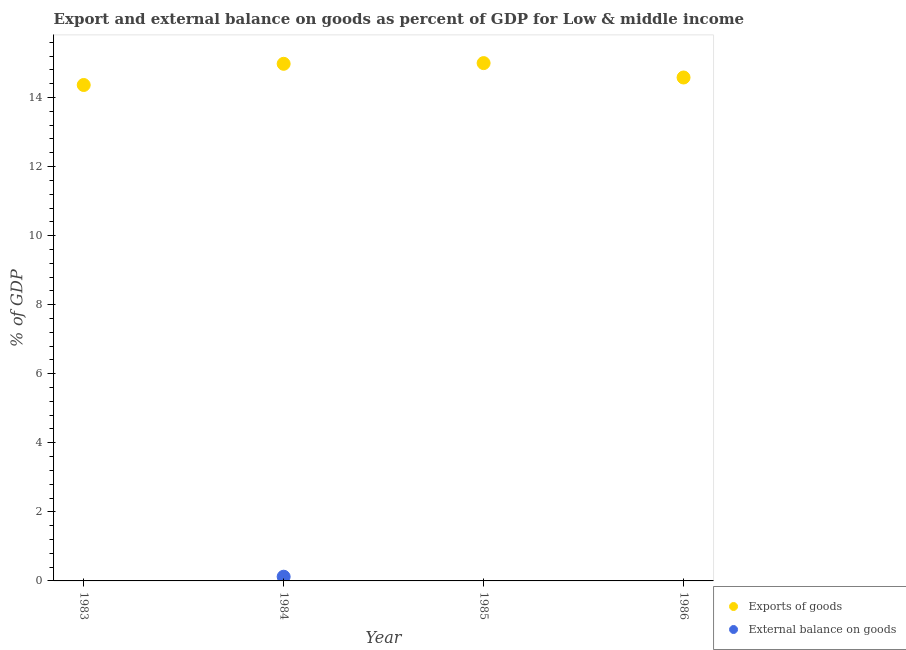Across all years, what is the maximum external balance on goods as percentage of gdp?
Your response must be concise. 0.12. Across all years, what is the minimum export of goods as percentage of gdp?
Offer a terse response. 14.36. What is the total export of goods as percentage of gdp in the graph?
Provide a succinct answer. 58.92. What is the difference between the export of goods as percentage of gdp in 1983 and that in 1986?
Make the answer very short. -0.22. What is the difference between the export of goods as percentage of gdp in 1985 and the external balance on goods as percentage of gdp in 1986?
Your answer should be compact. 15. What is the average external balance on goods as percentage of gdp per year?
Your answer should be very brief. 0.03. In the year 1984, what is the difference between the export of goods as percentage of gdp and external balance on goods as percentage of gdp?
Keep it short and to the point. 14.85. In how many years, is the external balance on goods as percentage of gdp greater than 4.4 %?
Provide a succinct answer. 0. What is the ratio of the export of goods as percentage of gdp in 1984 to that in 1985?
Your response must be concise. 1. What is the difference between the highest and the second highest export of goods as percentage of gdp?
Make the answer very short. 0.02. What is the difference between the highest and the lowest export of goods as percentage of gdp?
Ensure brevity in your answer.  0.63. In how many years, is the export of goods as percentage of gdp greater than the average export of goods as percentage of gdp taken over all years?
Ensure brevity in your answer.  2. Is the sum of the export of goods as percentage of gdp in 1985 and 1986 greater than the maximum external balance on goods as percentage of gdp across all years?
Your answer should be compact. Yes. Does the export of goods as percentage of gdp monotonically increase over the years?
Make the answer very short. No. Is the external balance on goods as percentage of gdp strictly greater than the export of goods as percentage of gdp over the years?
Your answer should be compact. No. How many dotlines are there?
Make the answer very short. 2. How many years are there in the graph?
Your answer should be compact. 4. How many legend labels are there?
Provide a succinct answer. 2. How are the legend labels stacked?
Make the answer very short. Vertical. What is the title of the graph?
Keep it short and to the point. Export and external balance on goods as percent of GDP for Low & middle income. What is the label or title of the Y-axis?
Make the answer very short. % of GDP. What is the % of GDP in Exports of goods in 1983?
Offer a terse response. 14.36. What is the % of GDP of External balance on goods in 1983?
Provide a short and direct response. 0. What is the % of GDP in Exports of goods in 1984?
Offer a very short reply. 14.98. What is the % of GDP in External balance on goods in 1984?
Your response must be concise. 0.12. What is the % of GDP of Exports of goods in 1985?
Provide a succinct answer. 15. What is the % of GDP in External balance on goods in 1985?
Make the answer very short. 0. What is the % of GDP of Exports of goods in 1986?
Your answer should be very brief. 14.58. Across all years, what is the maximum % of GDP in Exports of goods?
Offer a very short reply. 15. Across all years, what is the maximum % of GDP of External balance on goods?
Provide a short and direct response. 0.12. Across all years, what is the minimum % of GDP in Exports of goods?
Offer a very short reply. 14.36. What is the total % of GDP of Exports of goods in the graph?
Your answer should be compact. 58.91. What is the total % of GDP of External balance on goods in the graph?
Make the answer very short. 0.12. What is the difference between the % of GDP in Exports of goods in 1983 and that in 1984?
Your answer should be compact. -0.61. What is the difference between the % of GDP in Exports of goods in 1983 and that in 1985?
Provide a succinct answer. -0.63. What is the difference between the % of GDP in Exports of goods in 1983 and that in 1986?
Provide a succinct answer. -0.22. What is the difference between the % of GDP in Exports of goods in 1984 and that in 1985?
Give a very brief answer. -0.02. What is the difference between the % of GDP in Exports of goods in 1984 and that in 1986?
Your answer should be very brief. 0.4. What is the difference between the % of GDP of Exports of goods in 1985 and that in 1986?
Offer a terse response. 0.42. What is the difference between the % of GDP of Exports of goods in 1983 and the % of GDP of External balance on goods in 1984?
Make the answer very short. 14.24. What is the average % of GDP in Exports of goods per year?
Make the answer very short. 14.73. What is the average % of GDP in External balance on goods per year?
Ensure brevity in your answer.  0.03. In the year 1984, what is the difference between the % of GDP in Exports of goods and % of GDP in External balance on goods?
Keep it short and to the point. 14.85. What is the ratio of the % of GDP in Exports of goods in 1983 to that in 1984?
Ensure brevity in your answer.  0.96. What is the ratio of the % of GDP in Exports of goods in 1983 to that in 1985?
Offer a very short reply. 0.96. What is the ratio of the % of GDP of Exports of goods in 1983 to that in 1986?
Your answer should be very brief. 0.99. What is the ratio of the % of GDP in Exports of goods in 1984 to that in 1985?
Your answer should be very brief. 1. What is the ratio of the % of GDP of Exports of goods in 1984 to that in 1986?
Your answer should be compact. 1.03. What is the ratio of the % of GDP of Exports of goods in 1985 to that in 1986?
Make the answer very short. 1.03. What is the difference between the highest and the second highest % of GDP in Exports of goods?
Make the answer very short. 0.02. What is the difference between the highest and the lowest % of GDP of Exports of goods?
Offer a very short reply. 0.63. What is the difference between the highest and the lowest % of GDP in External balance on goods?
Your response must be concise. 0.12. 